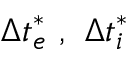<formula> <loc_0><loc_0><loc_500><loc_500>\Delta t _ { e } ^ { * } \ , \ \Delta t _ { i } ^ { * }</formula> 